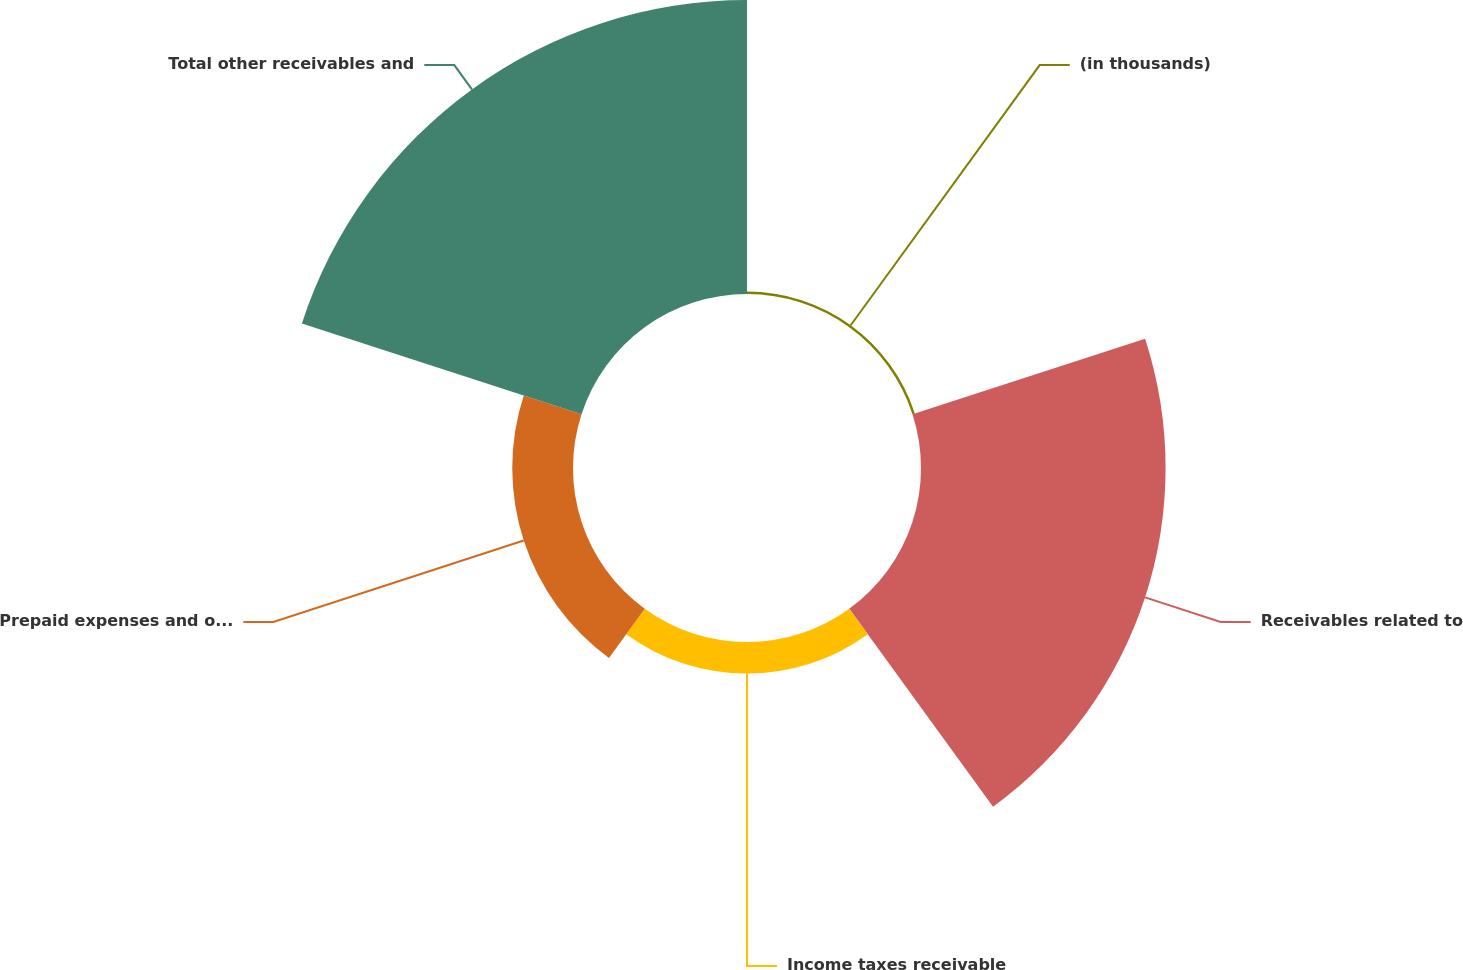<chart> <loc_0><loc_0><loc_500><loc_500><pie_chart><fcel>(in thousands)<fcel>Receivables related to<fcel>Income taxes receivable<fcel>Prepaid expenses and other<fcel>Total other receivables and<nl><fcel>0.39%<fcel>38.61%<fcel>4.99%<fcel>9.59%<fcel>46.41%<nl></chart> 